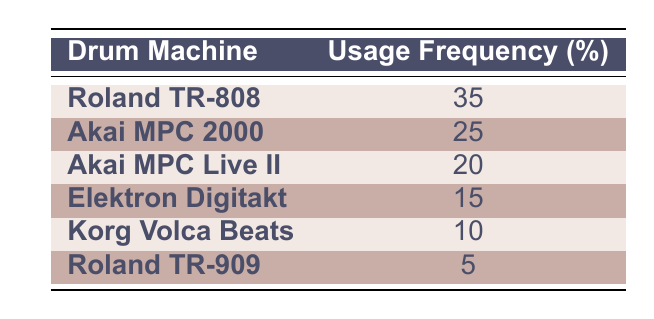What is the drum machine with the highest usage frequency? The table lists the usage frequencies for each drum machine, and by comparing the values, the Roland TR-808 has the highest usage frequency at 35%.
Answer: Roland TR-808 What is the usage frequency of the Akai MPC Live II? The table directly shows that the Akai MPC Live II has a usage frequency of 20%.
Answer: 20% How much more often is the Roland TR-808 used compared to the Roland TR-909? The Roland TR-808 has a usage frequency of 35%, and the Roland TR-909 has a frequency of 5%. The difference is 35% - 5% = 30%.
Answer: 30% Which drum machine has a usage frequency below 15%? Looking at the table, only the Roland TR-909 has a usage frequency of 5%, which is below 15%.
Answer: Yes, Roland TR-909 What is the average usage frequency of the drum machines listed? To find the average, sum the usage frequencies (35 + 25 + 20 + 15 + 10 + 5 = 110) and divide by the number of drum machines (6). So, 110 / 6 = 18.33%.
Answer: 18.33% Which two drum machines together have a combined usage frequency of 45%? By checking the values in the table, the Roland TR-808 (35%) and Akai MPC Live II (20%) add up to 55%. However, the only pair that sums to 45% is the Akai MPC 2000 (25%) and the Elektron Digitakt (15%), which totals to 40%.
Answer: No, there are no drum machines that combine to 45% What is the total usage frequency of all the drum machines? Adding all the usage frequencies together (35 + 25 + 20 + 15 + 10 + 5), we find the total is 110%.
Answer: 110% Is the usage frequency of the Elektron Digitakt higher than that of the Korg Volca Beats? The table indicates that the Elektron Digitakt has a frequency of 15% while Korg Volca Beats has a frequency of 10%. Therefore, the statement is true.
Answer: Yes 